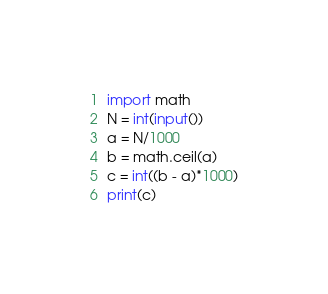<code> <loc_0><loc_0><loc_500><loc_500><_Python_>import math
N = int(input())
a = N/1000
b = math.ceil(a)
c = int((b - a)*1000)
print(c)</code> 